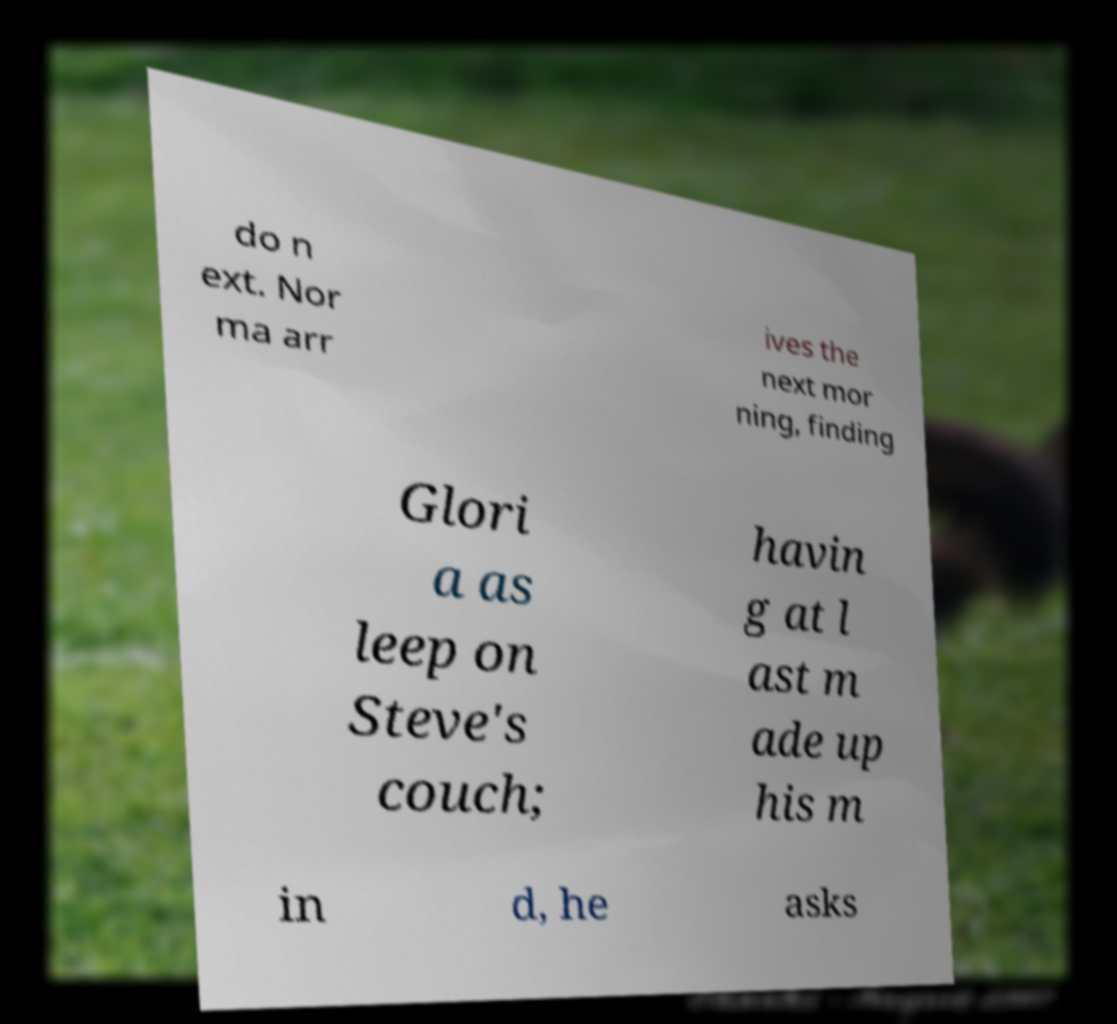There's text embedded in this image that I need extracted. Can you transcribe it verbatim? do n ext. Nor ma arr ives the next mor ning, finding Glori a as leep on Steve's couch; havin g at l ast m ade up his m in d, he asks 